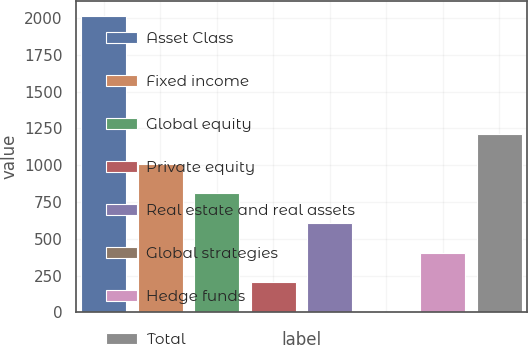Convert chart to OTSL. <chart><loc_0><loc_0><loc_500><loc_500><bar_chart><fcel>Asset Class<fcel>Fixed income<fcel>Global equity<fcel>Private equity<fcel>Real estate and real assets<fcel>Global strategies<fcel>Hedge funds<fcel>Total<nl><fcel>2014<fcel>1009<fcel>808<fcel>205<fcel>607<fcel>4<fcel>406<fcel>1210<nl></chart> 